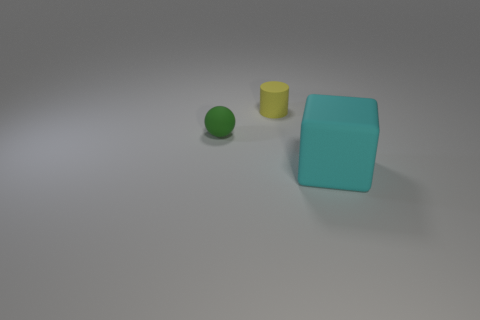What size is the rubber thing behind the small rubber thing that is left of the yellow matte object that is to the right of the green matte ball?
Provide a succinct answer. Small. Is the number of cyan things greater than the number of tiny red cylinders?
Your response must be concise. Yes. Is the small thing that is behind the small sphere made of the same material as the green object?
Offer a very short reply. Yes. Are there fewer matte blocks than big cyan metal cubes?
Your answer should be very brief. No. There is a tiny rubber thing left of the object that is behind the tiny green ball; are there any large things that are behind it?
Provide a succinct answer. No. There is a green rubber thing to the left of the yellow rubber object; does it have the same shape as the yellow matte object?
Your answer should be compact. No. Is the number of small rubber spheres to the right of the large cyan block greater than the number of cyan matte cubes?
Your response must be concise. No. Does the tiny thing that is right of the tiny green rubber thing have the same color as the large cube?
Give a very brief answer. No. Is there any other thing that is the same color as the rubber sphere?
Provide a short and direct response. No. The rubber thing that is in front of the small rubber object left of the tiny rubber thing on the right side of the ball is what color?
Give a very brief answer. Cyan. 